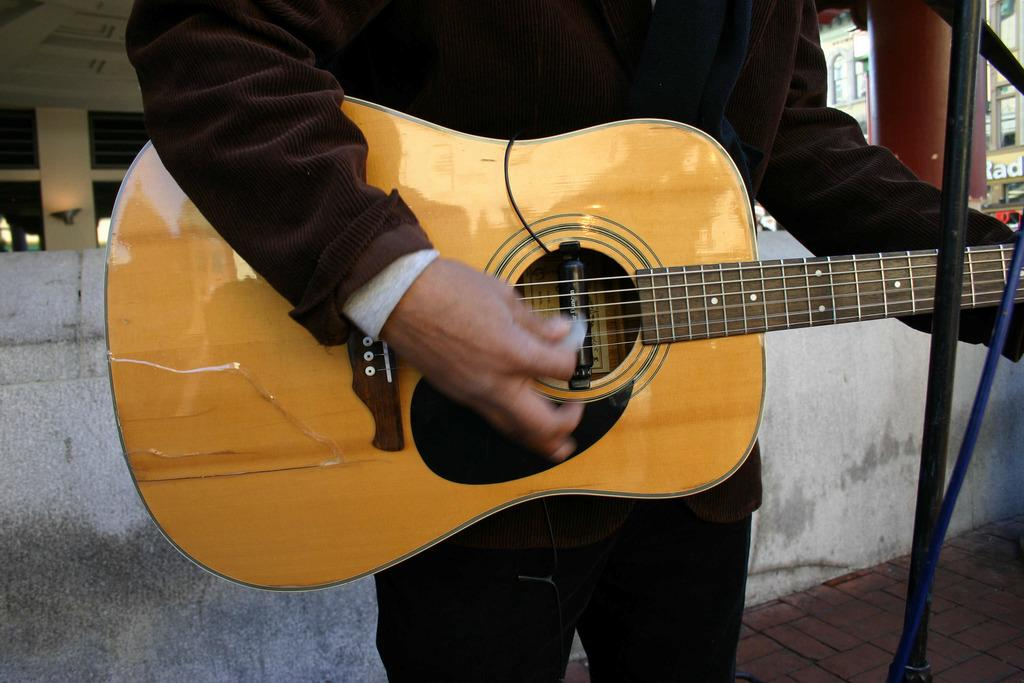What is the main focus of the image? The guitar is highlighted in the image. What is the person in the image doing with the guitar? A person is playing the guitar. What can be seen in the background of the image? There is a building with windows in the background of the image. What sense is being stimulated by the elbow in the image? There is no mention of an elbow in the image, so it cannot be determined which sense might be stimulated. 